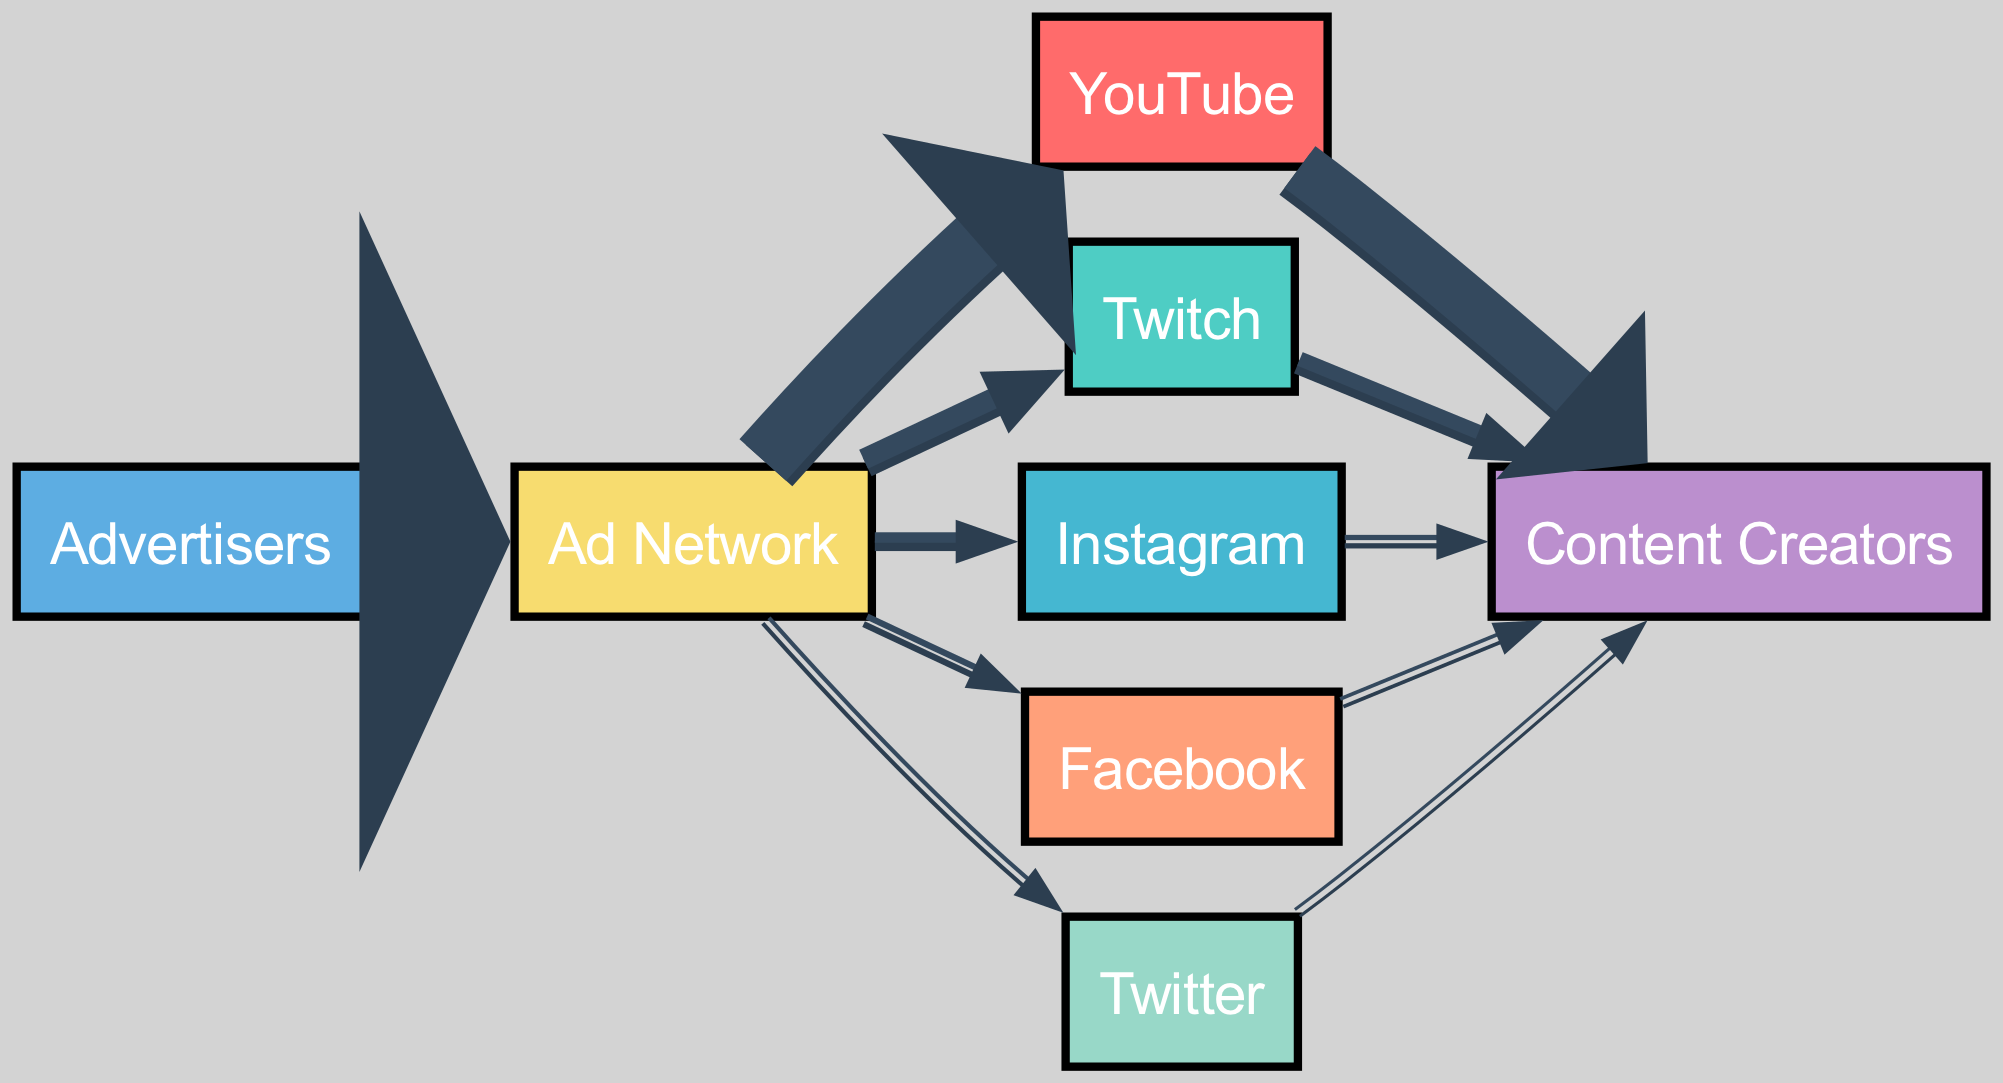What is the total amount of ad revenue from Advertisers to the Ad Network? The diagram clearly shows the flow from Advertisers to Ad Network with a value of 500. This indicates the entire revenue flowing from Advertisers to the Ad Network.
Answer: 500 Which platform receives the highest amount of ad revenue from the Ad Network? Looking at the flows from Ad Network to different platforms, YouTube has the highest value at 300, compared to Twitch, Instagram, Facebook, and Twitter.
Answer: YouTube How much revenue does Twitch generate for Content Creators? The flow from Twitch to Content Creators shows a value of 70, which represents the revenue generated for Content Creators specifically by Twitch.
Answer: 70 What percentage of the total ad revenue from the Ad Network goes to Facebook? The total revenue from Ad Network is 500 (300 + 100 + 50 + 30 + 20), leading to a total of 500. Facebook receives 30 from this, which is 30/500 = 0.06 or 6%.
Answer: 6% How many nodes are there in the diagram? By counting the unique entities in the nodes list, we have 8 distinct nodes representing platforms and entities related to ad revenue flow.
Answer: 8 How much total revenue do Content Creators earn from all platforms combined? Adding the amounts received by Content Creators from each platform: 250 (YouTube) + 70 (Twitch) + 25 (Instagram) + 18 (Facebook) + 15 (Twitter) gives a total of 378.
Answer: 378 Which social media platform receives the least ad revenue from the Ad Network? Comparing the values from Ad Network to social media platforms, Twitter receives only 20, which is the lowest among Instagram, Facebook, and itself.
Answer: Twitter What is the total ad revenue directed to Content Creators from YouTube? The flow directly from YouTube to Content Creators shows a value of 250, solely representing the revenue directed to them from this platform.
Answer: 250 